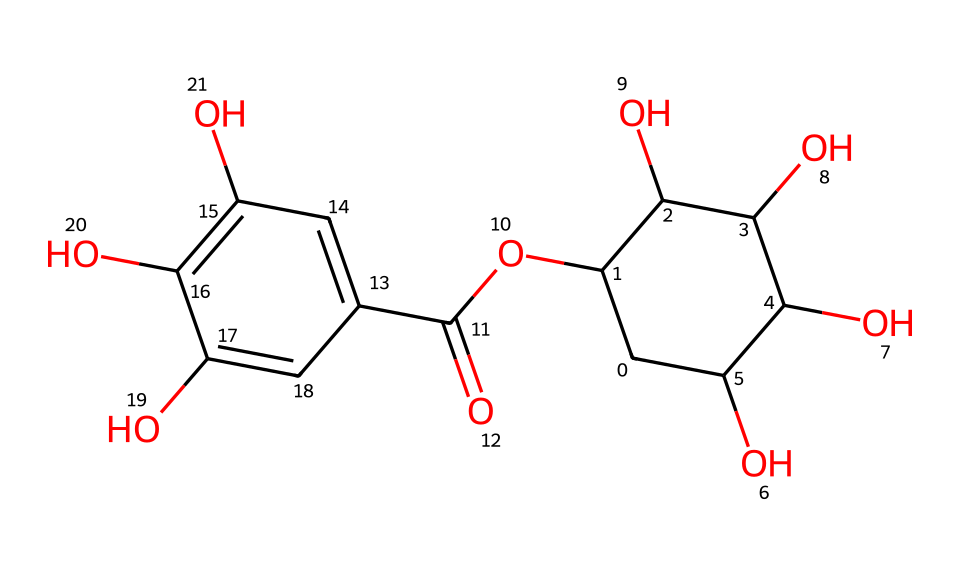What is the main functional group present in tannic acid? The SMILES representation shows multiple "O" atoms, specifically hydroxyl (-OH) groups, indicating a significant presence of alcohol functional groups alongside the ester functionality.
Answer: hydroxyl How many carbohydrate units are part of the molecular structure? By analyzing the structure, one can identify that there are five hydroxylated carbon units contributing to the carbohydrate presence in the tannic acid structure.
Answer: five What type of organic compound is tannic acid? The chemical structure features acidic functional groups, particularly observed in the presence of the carboxylic acid group (-COOH), which categorizes it as an acid.
Answer: polyphenolic acid How many total carbon atoms are there in tannic acid? By examining the SMILES representation, we can count the carbon atoms, which reveals that there are 15 carbon atoms present in the tannic acid structure.
Answer: fifteen What is the total number of hydroxyl groups in the structure of tannic acid? The SMILES shows several "-OH" groups throughout, leading to the calculation that there are six hydroxyl groups present in the tannic acid molecule.
Answer: six What visual feature indicates the presence of aromatic compounds in tannic acid? The presence of alternating double bonds and the cyclic structure demonstrates features characteristic of aromatic compounds, most clearly seen in the phenolic rings of tannic acid.
Answer: aromatic rings 